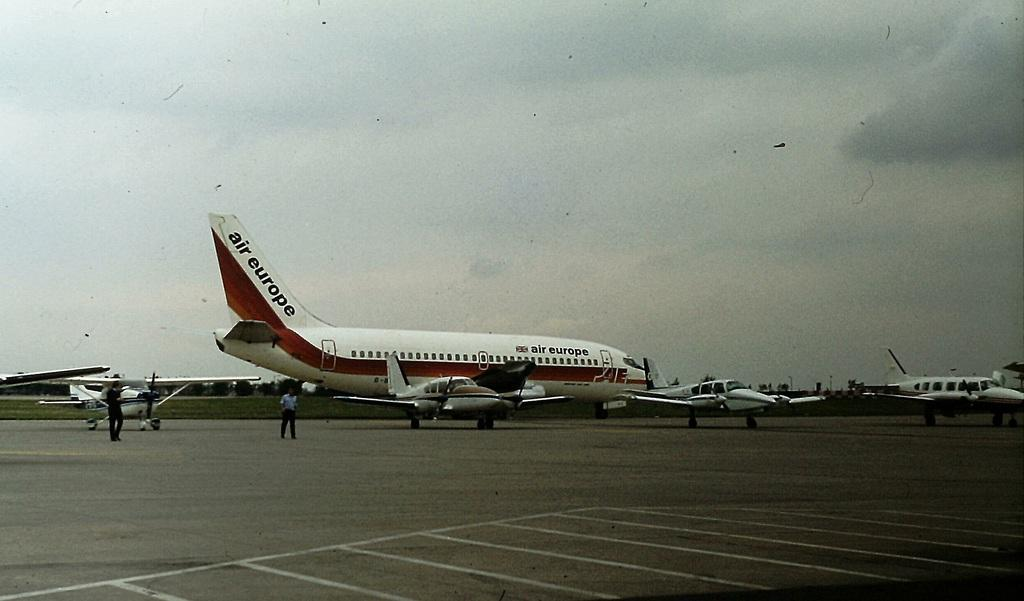Provide a one-sentence caption for the provided image. The jet plane on the runway says Air Europe. 